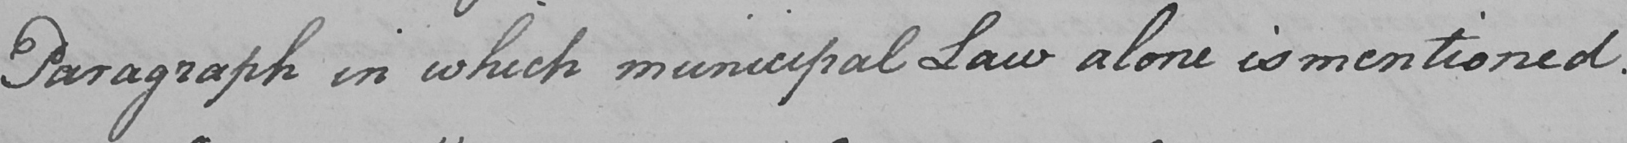Please transcribe the handwritten text in this image. Paragraph in which municipal Law alone is mentioned . 